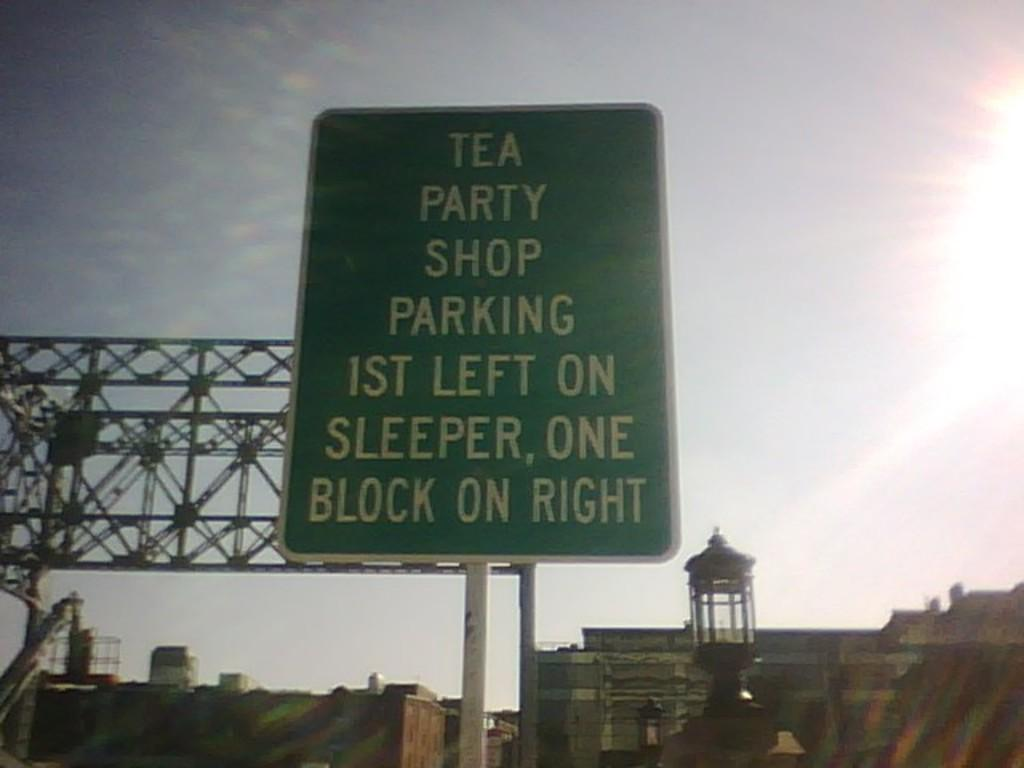Provide a one-sentence caption for the provided image. A sign which indicates directions for the parking area for a the Tea Party Shop. 